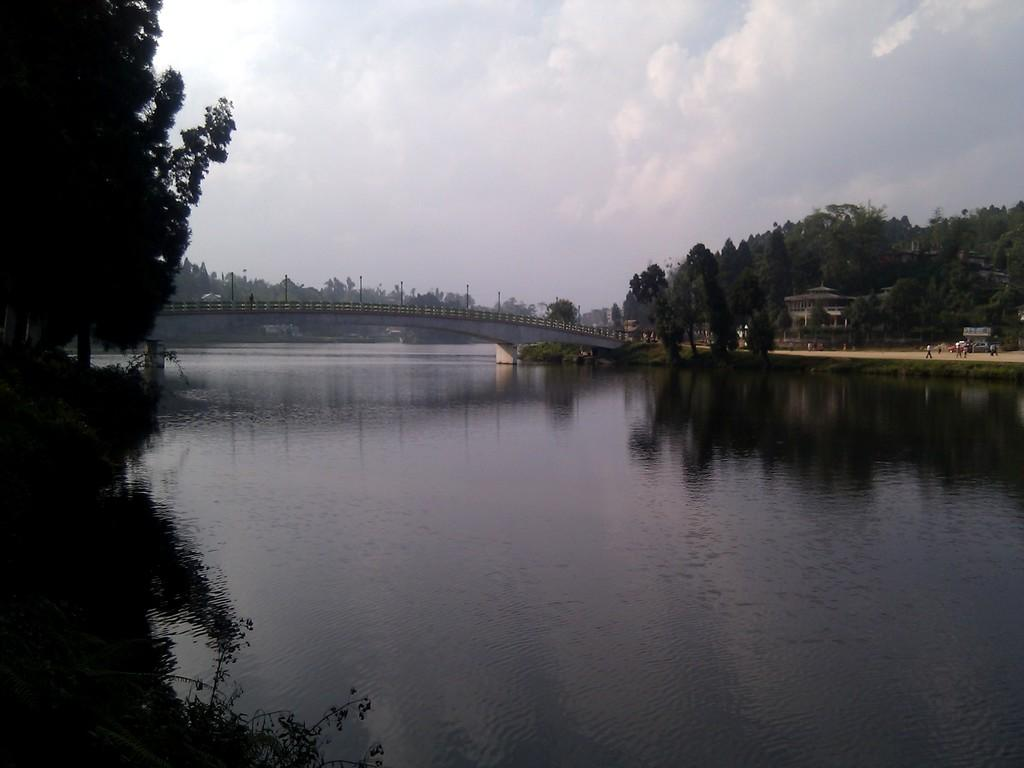What type of natural elements can be seen in the image? There are trees and water visible in the image. What man-made structure is present in the image? There is a bridge in the image. Where are the people located in the image? The people are on the right side of the image. What other man-made structure is present on the right side of the image? There is a building on the right side of the image. What is visible in the background of the image? The sky is visible in the background of the image. What type of disease is affecting the trees in the image? There is no indication of any disease affecting the trees in the image; they appear healthy. Can you tell me how many dinosaurs are visible in the image? There are no dinosaurs present in the image. 